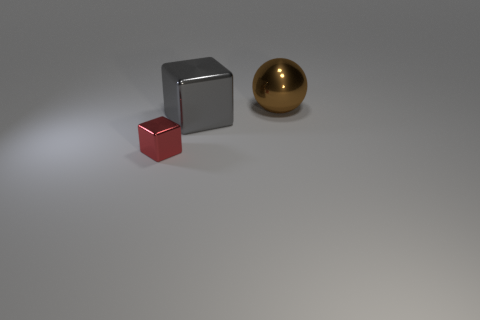Is there any other thing that is the same size as the red metal thing?
Offer a terse response. No. There is a sphere; does it have the same size as the metallic object on the left side of the big gray block?
Give a very brief answer. No. Are there any other things that have the same shape as the brown object?
Provide a short and direct response. No. There is a big metal object that is the same shape as the tiny red thing; what color is it?
Provide a short and direct response. Gray. Does the ball have the same size as the red metallic thing?
Provide a short and direct response. No. How many other things are there of the same size as the gray metallic cube?
Offer a very short reply. 1. What number of objects are large gray metallic cubes that are on the right side of the tiny red thing or big metal objects that are left of the big brown metallic thing?
Ensure brevity in your answer.  1. What is the shape of the other shiny thing that is the same size as the brown thing?
Provide a short and direct response. Cube. What size is the red object that is made of the same material as the sphere?
Offer a very short reply. Small. Is the shape of the small shiny object the same as the gray object?
Your response must be concise. Yes. 